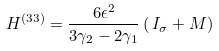Convert formula to latex. <formula><loc_0><loc_0><loc_500><loc_500>H ^ { ( 3 3 ) } = \frac { 6 \epsilon ^ { 2 } } { 3 \gamma _ { 2 } - 2 \gamma _ { 1 } } \left ( \, I _ { \sigma } + M \right )</formula> 